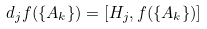<formula> <loc_0><loc_0><loc_500><loc_500>d _ { j } f ( \{ A _ { k } \} ) = [ H _ { j } , f ( \{ A _ { k } \} ) ]</formula> 